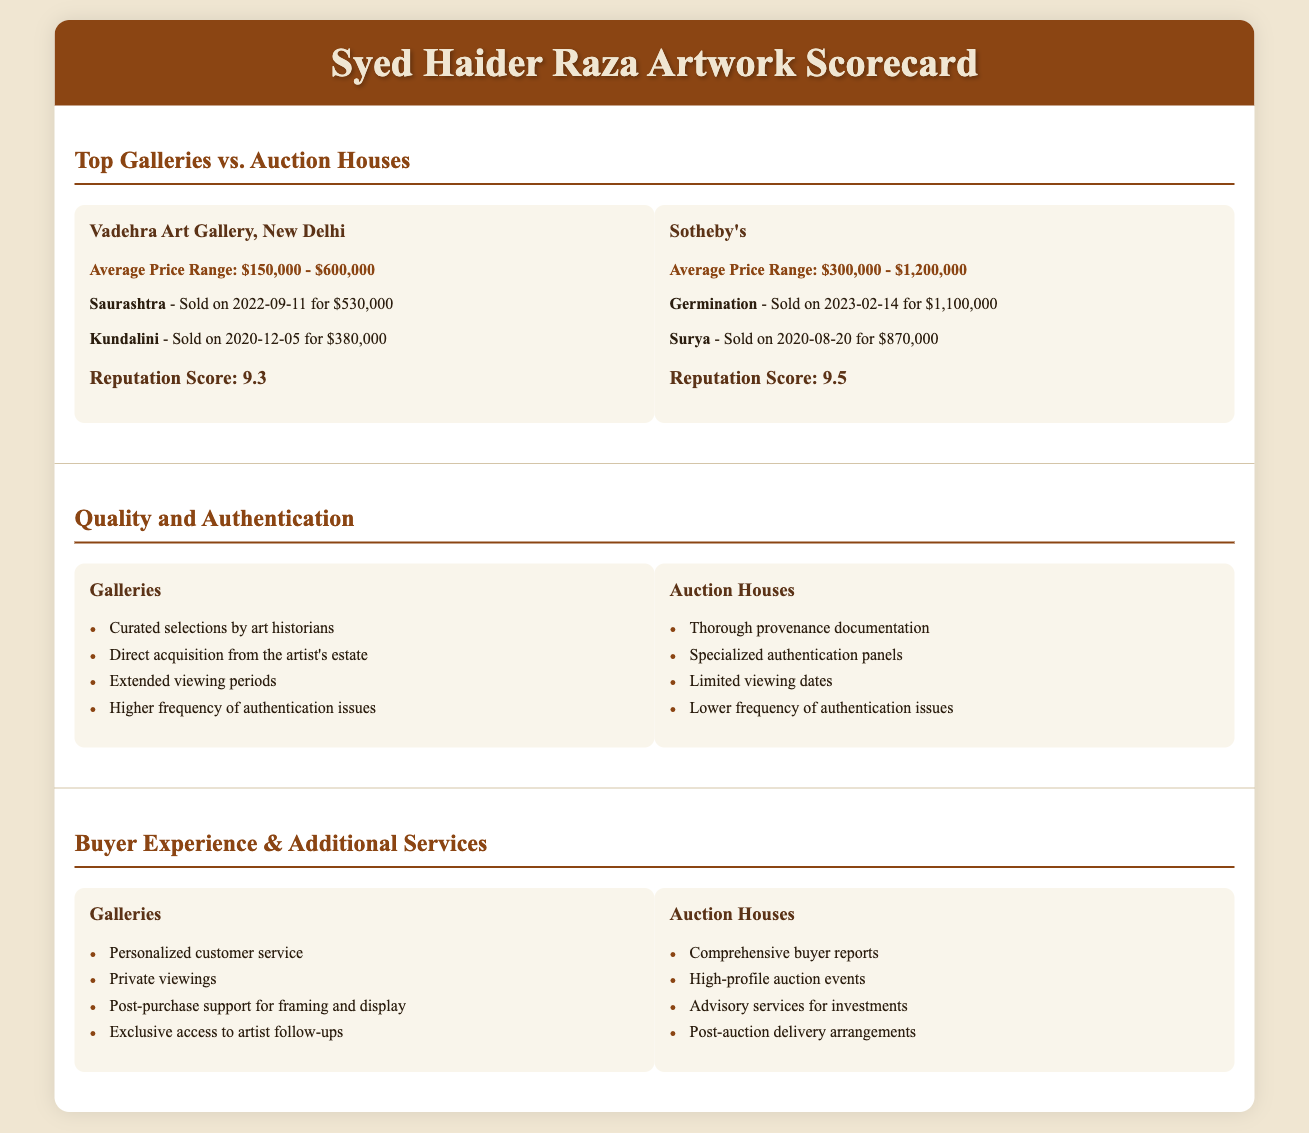what is the average price range for Vadehra Art Gallery? The average price range for Vadehra Art Gallery is mentioned explicitly in the document.
Answer: $150,000 - $600,000 who sold the artwork "Surya"? The document states that "Surya" was sold by Sotheby's.
Answer: Sotheby's what is the reputation score of Sotheby's? The reputation score is clearly defined in the document for Sotheby's.
Answer: 9.5 what common issue is highlighted for galleries regarding authenticity? The document points out an issue common to galleries concerning authentication.
Answer: Higher frequency of authentication issues what type of buyer experience does a gallery offer? The document lists buyer experiences provided by galleries under their services.
Answer: Personalized customer service what is the maximum average price range for auction houses? The maximum average price range is specified in the auction houses section.
Answer: $1,200,000 how does the auction houses' authentication frequency compare to galleries? The document compares the frequency of authentication issues between auction houses and galleries.
Answer: Lower frequency of authentication issues which artwork was sold for $1,100,000? The document provides details about artworks sold at specific prices, including one at this price.
Answer: Germination 